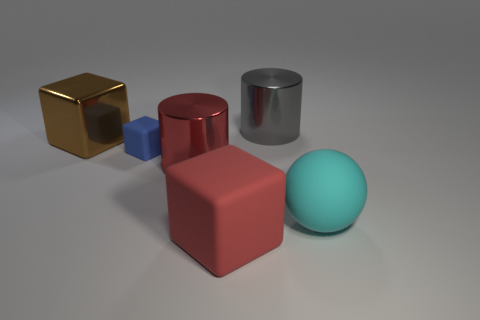Do the blue object and the red rubber block have the same size?
Your response must be concise. No. There is a brown object behind the big matte object that is in front of the large cyan matte object; is there a gray metallic cylinder to the right of it?
Give a very brief answer. Yes. What material is the big red object that is the same shape as the blue thing?
Provide a succinct answer. Rubber. There is a big cube that is to the right of the blue matte thing; how many big red metal objects are in front of it?
Your answer should be compact. 0. What size is the red thing that is in front of the large matte thing that is to the right of the cylinder that is right of the red block?
Offer a terse response. Large. There is a rubber object that is to the right of the cylinder behind the small blue object; what is its color?
Your answer should be very brief. Cyan. What number of other objects are the same material as the big cyan thing?
Provide a succinct answer. 2. What number of other things are there of the same color as the small cube?
Your answer should be compact. 0. What material is the block that is to the left of the matte block that is behind the big cyan rubber ball?
Provide a succinct answer. Metal. Are any large brown spheres visible?
Keep it short and to the point. No. 